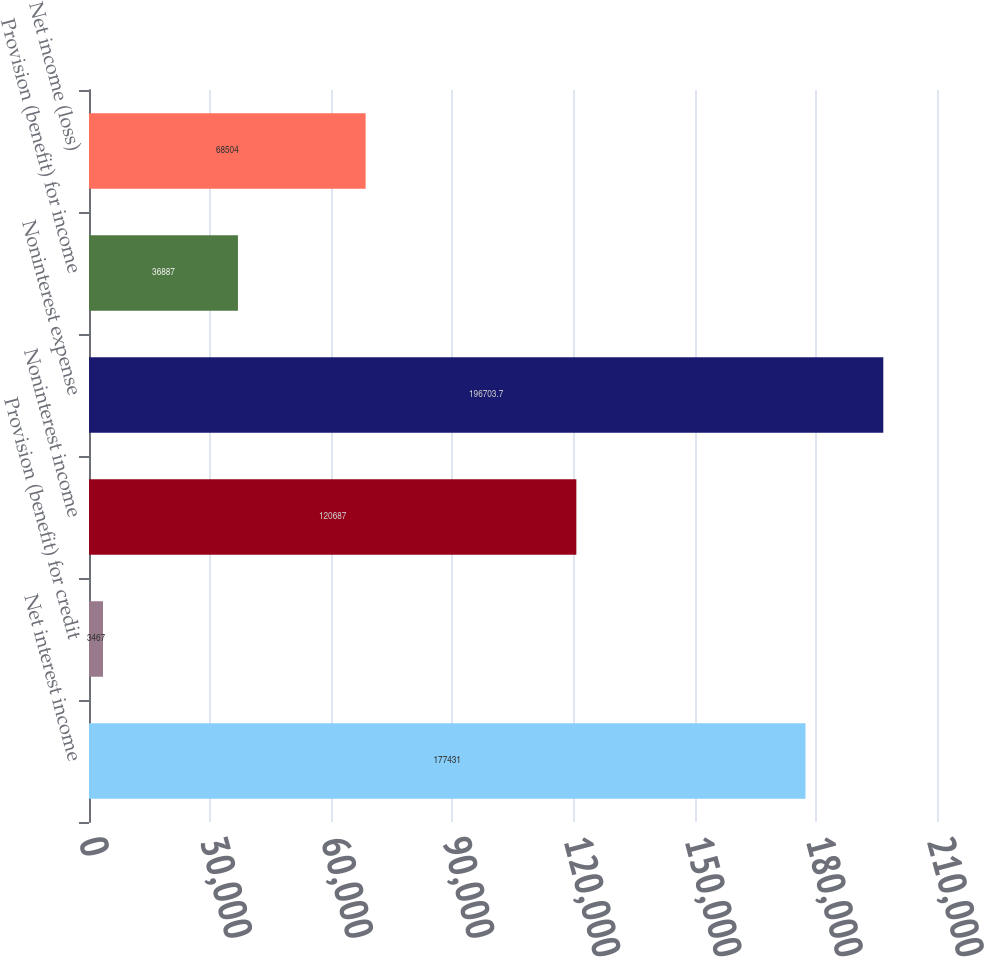<chart> <loc_0><loc_0><loc_500><loc_500><bar_chart><fcel>Net interest income<fcel>Provision (benefit) for credit<fcel>Noninterest income<fcel>Noninterest expense<fcel>Provision (benefit) for income<fcel>Net income (loss)<nl><fcel>177431<fcel>3467<fcel>120687<fcel>196704<fcel>36887<fcel>68504<nl></chart> 